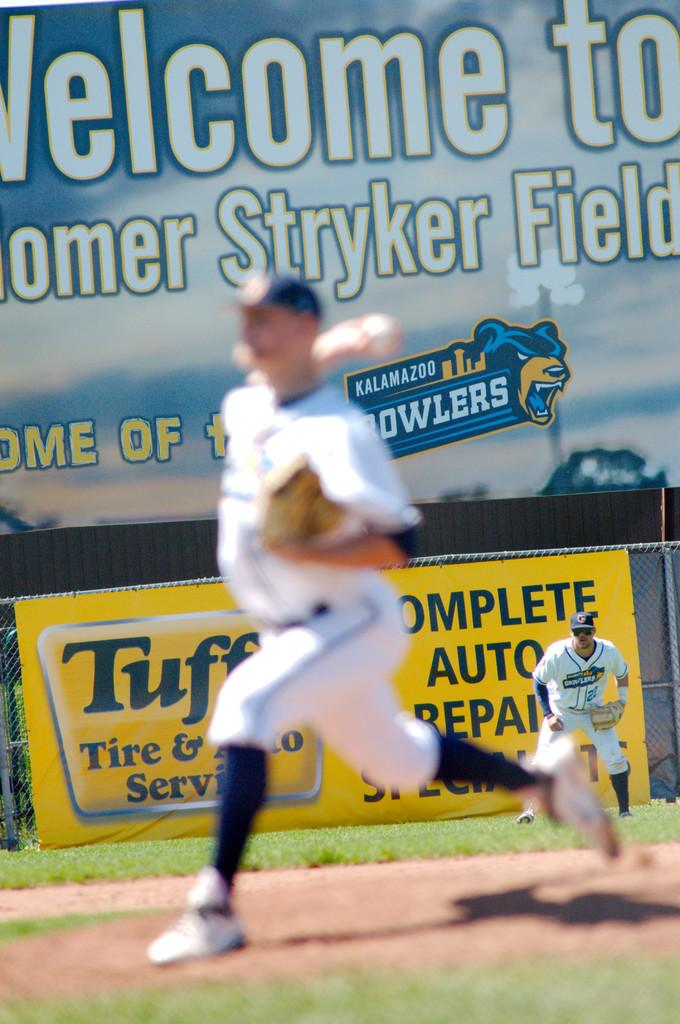<image>
Describe the image concisely. A player stands in the outfield in front of a sign that says "Welcome to Stryker Field" 